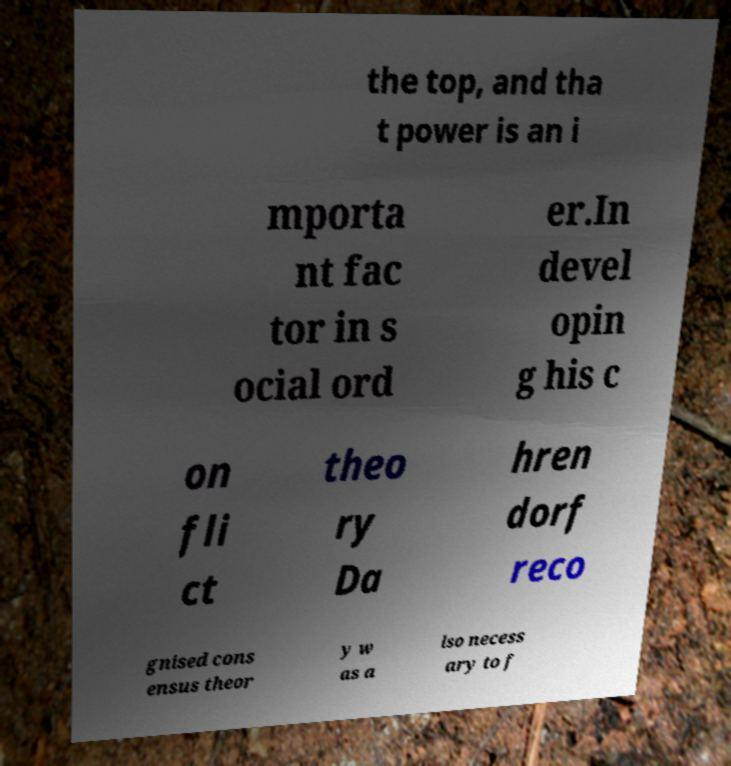Can you read and provide the text displayed in the image?This photo seems to have some interesting text. Can you extract and type it out for me? the top, and tha t power is an i mporta nt fac tor in s ocial ord er.In devel opin g his c on fli ct theo ry Da hren dorf reco gnised cons ensus theor y w as a lso necess ary to f 